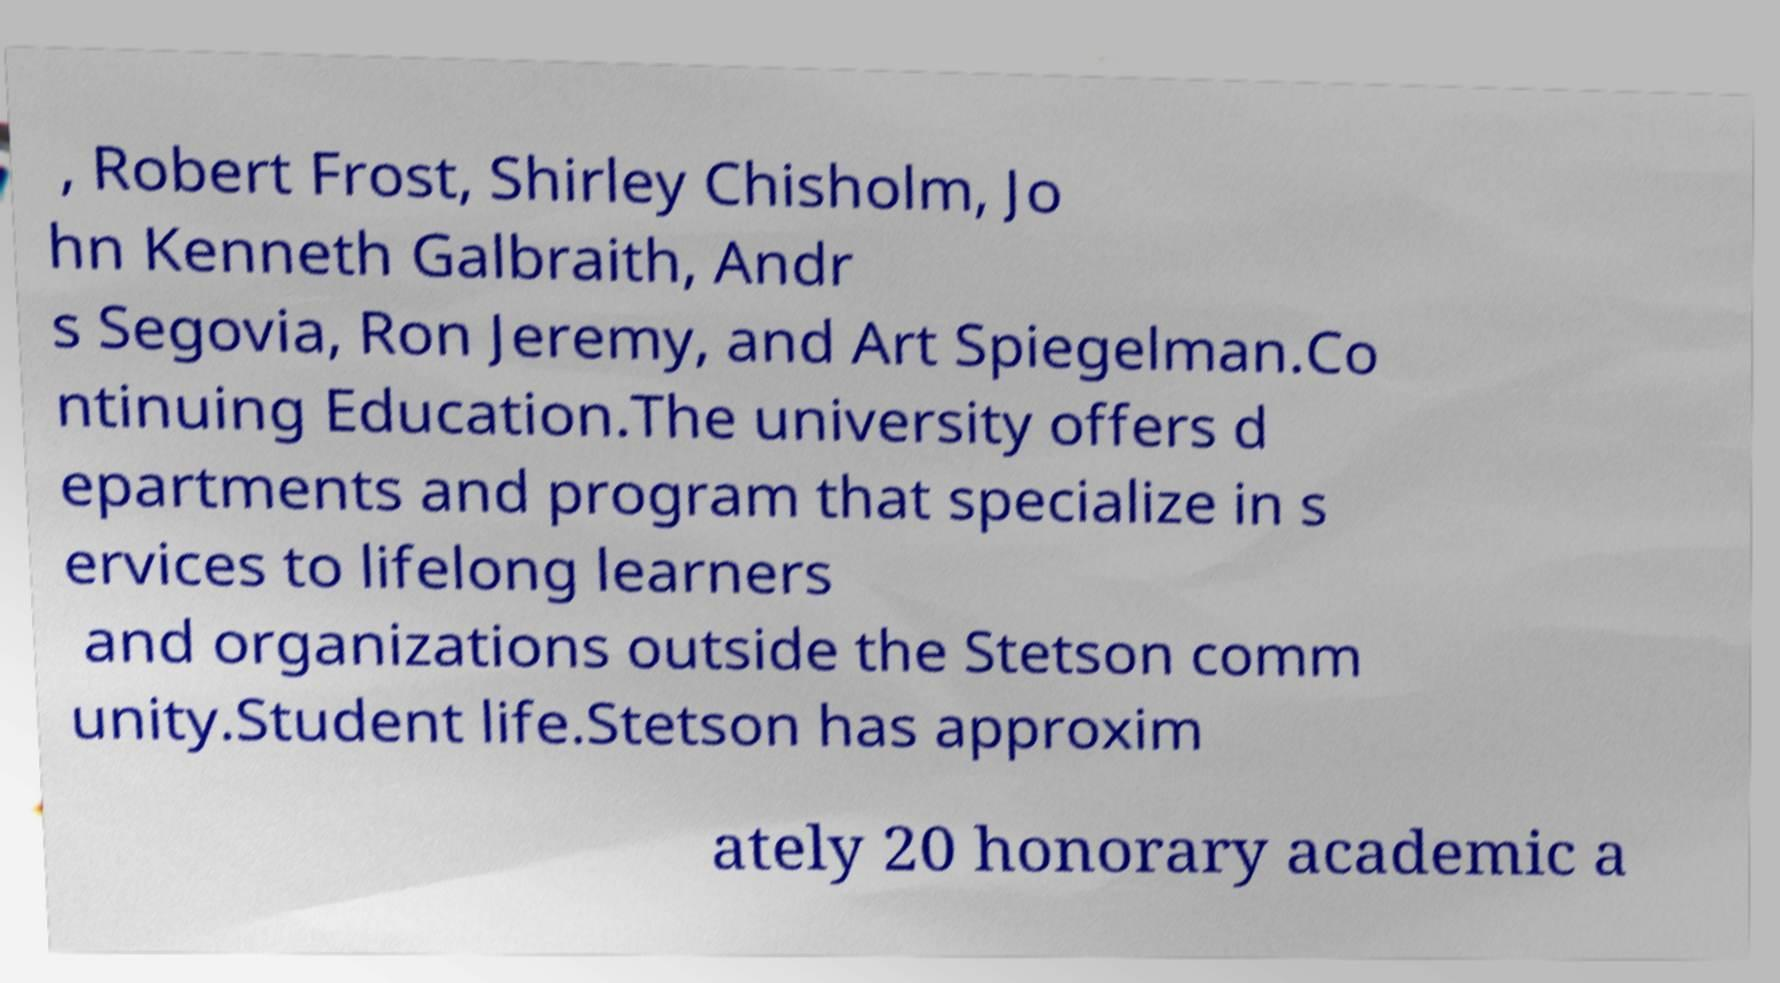Please identify and transcribe the text found in this image. , Robert Frost, Shirley Chisholm, Jo hn Kenneth Galbraith, Andr s Segovia, Ron Jeremy, and Art Spiegelman.Co ntinuing Education.The university offers d epartments and program that specialize in s ervices to lifelong learners and organizations outside the Stetson comm unity.Student life.Stetson has approxim ately 20 honorary academic a 